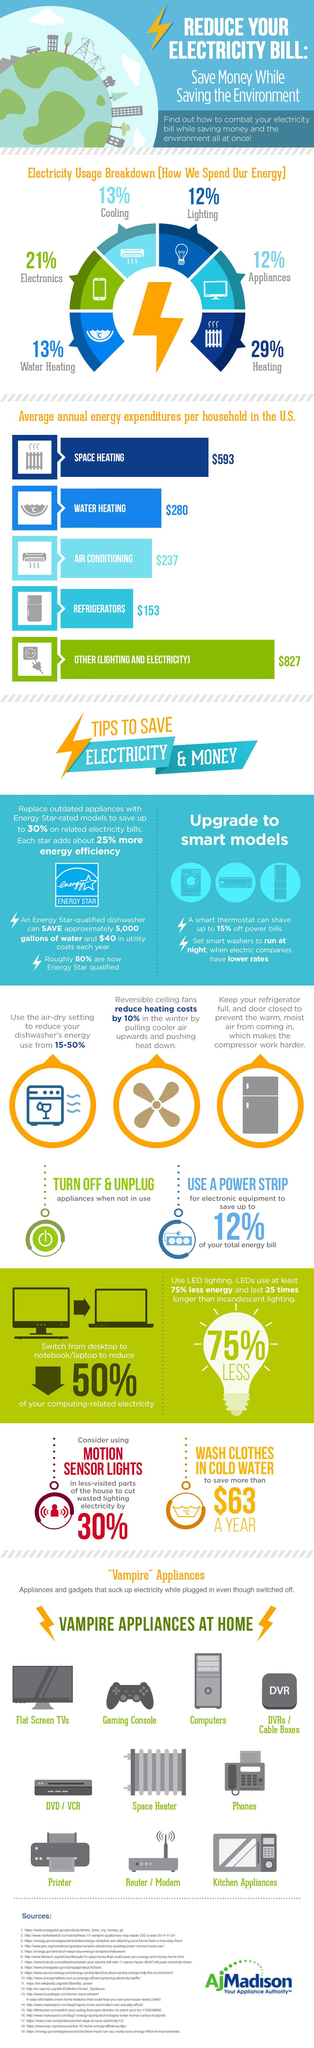Highlight a few significant elements in this photo. Nine appliances consume electricity even when they are not plugged in. If a household had a well-lit home with a refrigerator and water heater, they would incur an expenditure of $1,260 in dollars. Which appliance uses a major chunk of energy produced, heating appliances, electronic devices, or lighting devices? Heating appliances, which account for a significant portion of energy consumption, are the answer. Approximately 13% of the electricity consumed in the United States is used for cooling and water heating appliances. 